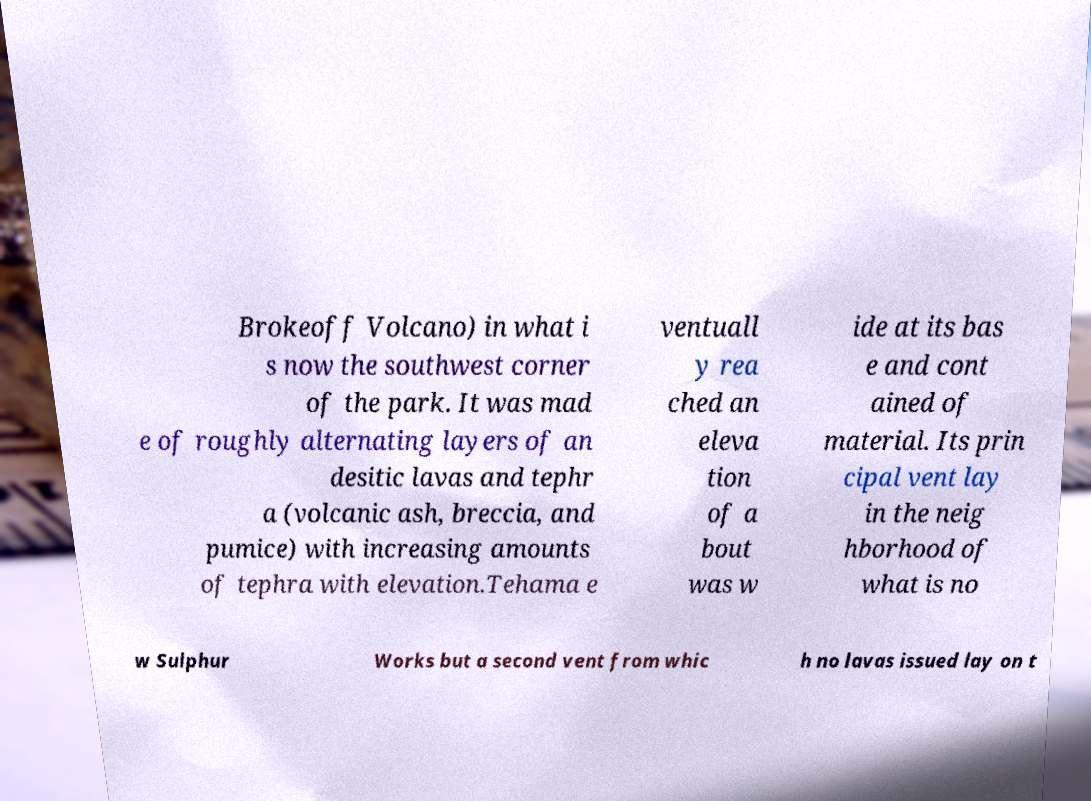There's text embedded in this image that I need extracted. Can you transcribe it verbatim? Brokeoff Volcano) in what i s now the southwest corner of the park. It was mad e of roughly alternating layers of an desitic lavas and tephr a (volcanic ash, breccia, and pumice) with increasing amounts of tephra with elevation.Tehama e ventuall y rea ched an eleva tion of a bout was w ide at its bas e and cont ained of material. Its prin cipal vent lay in the neig hborhood of what is no w Sulphur Works but a second vent from whic h no lavas issued lay on t 